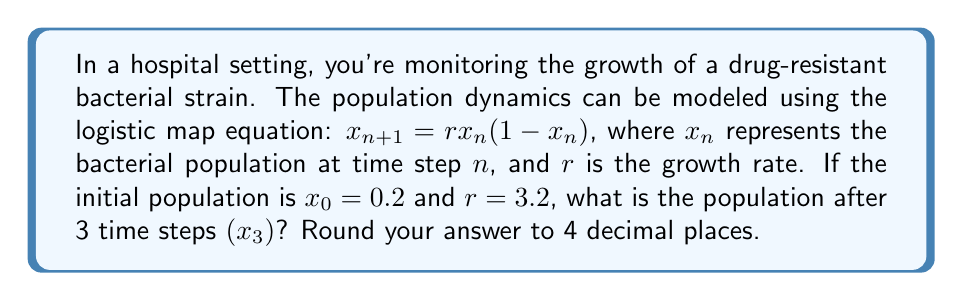Teach me how to tackle this problem. To solve this problem, we need to iterate the logistic map equation three times:

Step 1: Calculate $x_1$
$$x_1 = r \cdot x_0 \cdot (1-x_0)$$
$$x_1 = 3.2 \cdot 0.2 \cdot (1-0.2)$$
$$x_1 = 3.2 \cdot 0.2 \cdot 0.8 = 0.512$$

Step 2: Calculate $x_2$
$$x_2 = r \cdot x_1 \cdot (1-x_1)$$
$$x_2 = 3.2 \cdot 0.512 \cdot (1-0.512)$$
$$x_2 = 3.2 \cdot 0.512 \cdot 0.488 = 0.7995$$

Step 3: Calculate $x_3$
$$x_3 = r \cdot x_2 \cdot (1-x_2)$$
$$x_3 = 3.2 \cdot 0.7995 \cdot (1-0.7995)$$
$$x_3 = 3.2 \cdot 0.7995 \cdot 0.2005 = 0.5132$$

Step 4: Round to 4 decimal places
$x_3 \approx 0.5132$
Answer: 0.5132 